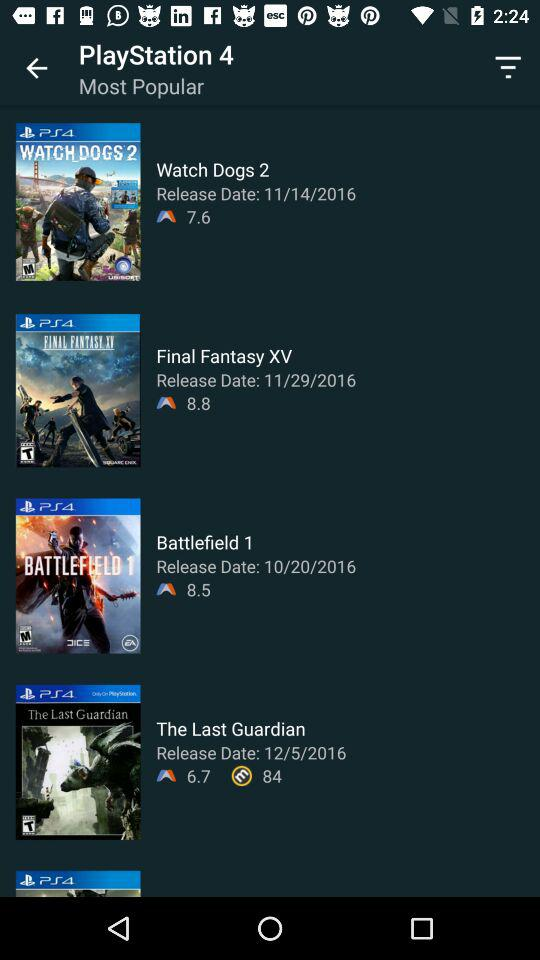What is the release date of "Final Fantasy XV"? The release date of "Final Fantasy XV" is November 29, 2016. 